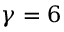<formula> <loc_0><loc_0><loc_500><loc_500>\gamma = 6</formula> 